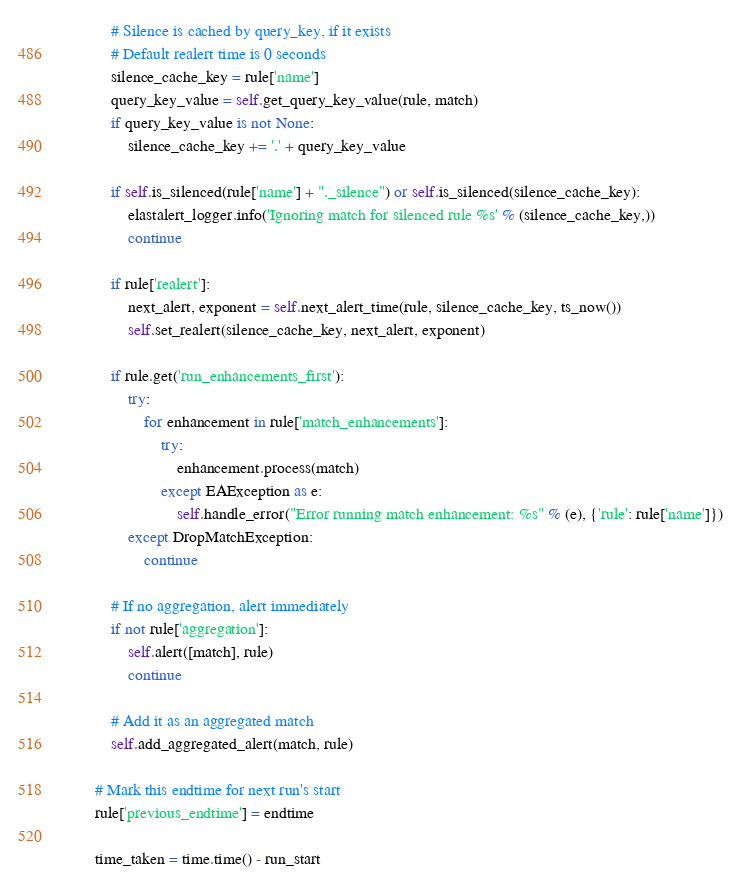<code> <loc_0><loc_0><loc_500><loc_500><_Python_>            # Silence is cached by query_key, if it exists
            # Default realert time is 0 seconds
            silence_cache_key = rule['name']
            query_key_value = self.get_query_key_value(rule, match)
            if query_key_value is not None:
                silence_cache_key += '.' + query_key_value

            if self.is_silenced(rule['name'] + "._silence") or self.is_silenced(silence_cache_key):
                elastalert_logger.info('Ignoring match for silenced rule %s' % (silence_cache_key,))
                continue

            if rule['realert']:
                next_alert, exponent = self.next_alert_time(rule, silence_cache_key, ts_now())
                self.set_realert(silence_cache_key, next_alert, exponent)

            if rule.get('run_enhancements_first'):
                try:
                    for enhancement in rule['match_enhancements']:
                        try:
                            enhancement.process(match)
                        except EAException as e:
                            self.handle_error("Error running match enhancement: %s" % (e), {'rule': rule['name']})
                except DropMatchException:
                    continue

            # If no aggregation, alert immediately
            if not rule['aggregation']:
                self.alert([match], rule)
                continue

            # Add it as an aggregated match
            self.add_aggregated_alert(match, rule)

        # Mark this endtime for next run's start
        rule['previous_endtime'] = endtime

        time_taken = time.time() - run_start</code> 